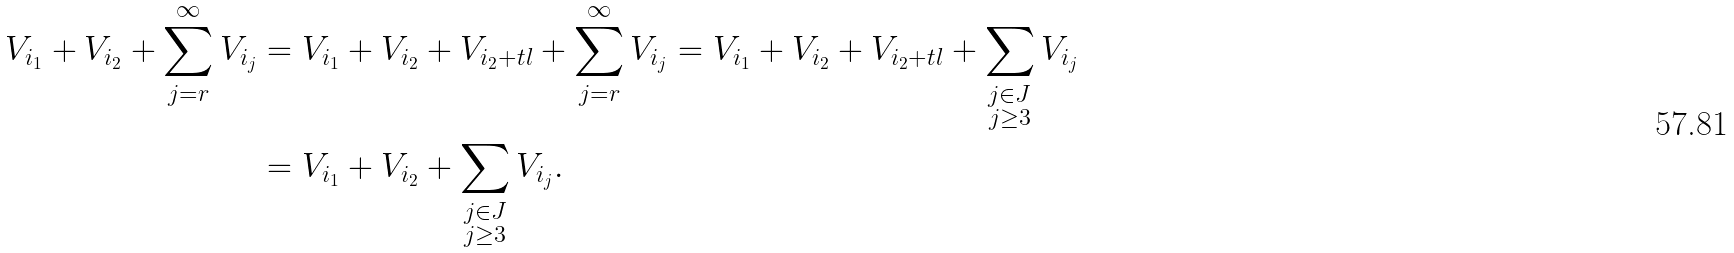Convert formula to latex. <formula><loc_0><loc_0><loc_500><loc_500>V _ { i _ { 1 } } + V _ { i _ { 2 } } + \sum _ { j = r } ^ { \infty } V _ { i _ { j } } & = V _ { i _ { 1 } } + V _ { i _ { 2 } } + V _ { i _ { 2 } + t l } + \sum _ { j = r } ^ { \infty } V _ { i _ { j } } = V _ { i _ { 1 } } + V _ { i _ { 2 } } + V _ { i _ { 2 } + t l } + \sum _ { \substack { j \in J \\ j \geq 3 } } V _ { i _ { j } } \\ & = V _ { i _ { 1 } } + V _ { i _ { 2 } } + \sum _ { \substack { j \in J \\ j \geq 3 } } V _ { i _ { j } } .</formula> 